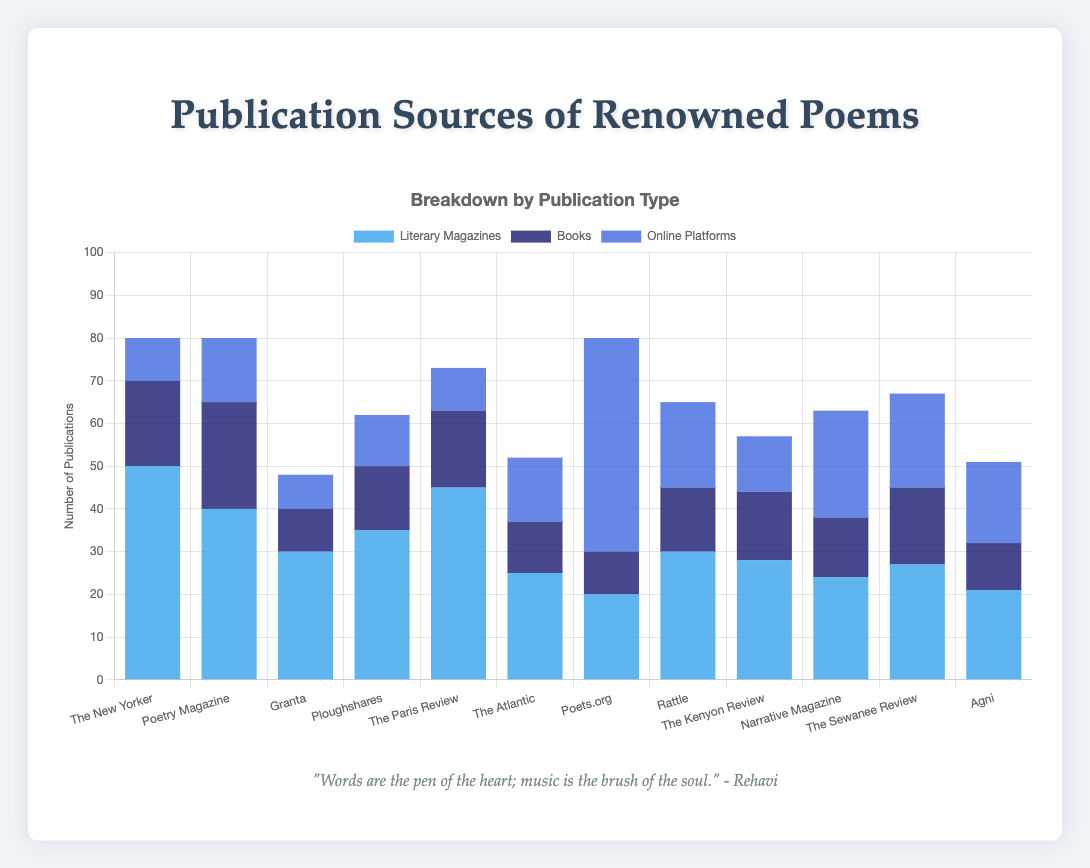Which publication source has the highest number of poems published in literary magazines? The New Yorker has the highest bar for literary magazines, indicating it has published the most poems in this category.
Answer: The New Yorker Which platform has the highest number of poems published online? Poets.org has the highest bar in the online platforms category, indicating it has published the most poems online.
Answer: Poets.org Compare the total number of poems published by The New Yorker and Poetry Magazine. Which one is higher? Summing the values for Literary Magazines, Books, and Online Platforms for each: The New Yorker (50 + 20 + 10 = 80) and Poetry Magazine (40 + 25 + 15 = 80). Both have the same total.
Answer: They are equal What is the total number of poems published by Ploughshares across all platforms? Summing the values for Literary Magazines, Books, and Online Platforms for Ploughshares: 35 + 15 + 12 = 62.
Answer: 62 How many more poems are published in books by Poetry Magazine compared to The Atlantic? Poetry Magazine has 25 poems in books, and The Atlantic has 12. The difference is 25 - 12 = 13.
Answer: 13 Which publication source has the smallest number of poems published in literary magazines? Agni has the lowest bar for literary magazines with a value of 21.
Answer: Agni Which two publication sources have the same number of poems published online? The New Yorker and The Paris Review both have 10 poems published online.
Answer: The New Yorker and The Paris Review What is the average number of poems published in books by The New Yorker, Granta, and Agni? Sum the books published by these sources: 20 (The New Yorker) + 10 (Granta) + 11 (Agni) = 41. The average is 41/3 ≈ 13.67.
Answer: 13.67 Is the number of poems published online by Rattle more than the total number of poems published by Granta? Rattle has 20 poems published online. Granta has a total of 30 (Literary Magazines) + 10 (Books) + 8 (Online) = 48. Since 20 < 48, it is not more.
Answer: No How does the number of poems published by The Kenyon Review in books compare to those published online by the same source? The Kenyon Review has 16 poems published in books and 13 published online. 16 is greater than 13.
Answer: More in books 